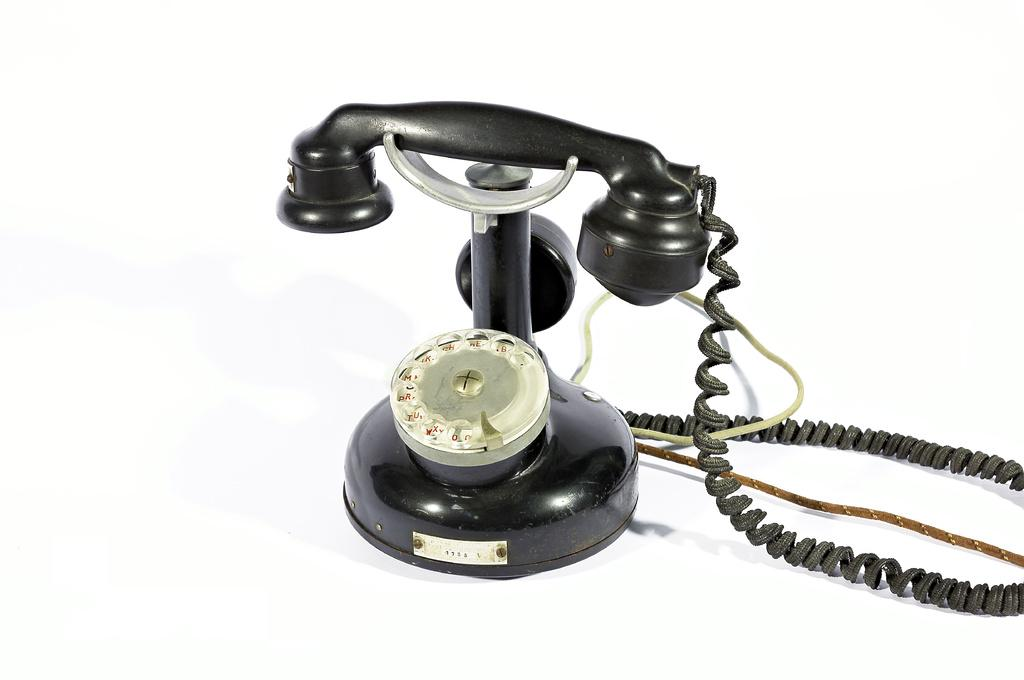What type of telephone is in the image? There is a black color telephone in the image. What can be seen behind the glass of the telephone? There are numbers visible behind the glass of the telephone. What is written or printed in the image? There is text visible in the image. What is connected to the telephone? There are wires associated with the telephone. What color is the background of the image? The background of the image is white. Can you see a robin perched on the telephone in the image? No, there is no robin present in the image. What type of horn is attached to the telephone in the image? There is no horn attached to the telephone in the image. 